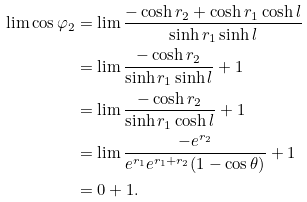<formula> <loc_0><loc_0><loc_500><loc_500>\lim \cos \varphi _ { 2 } & = \lim \frac { - \cosh r _ { 2 } + \cosh r _ { 1 } \cosh l } { \sinh r _ { 1 } \sinh l } \\ & = \lim \frac { - \cosh r _ { 2 } } { \sinh r _ { 1 } \sinh l } + 1 \\ & = \lim \frac { - \cosh r _ { 2 } } { \sinh r _ { 1 } \cosh l } + 1 \\ & = \lim \frac { - e ^ { r _ { 2 } } } { e ^ { r _ { 1 } } e ^ { r _ { 1 } + r _ { 2 } } ( 1 - \cos \theta ) } + 1 \\ & = 0 + 1 .</formula> 